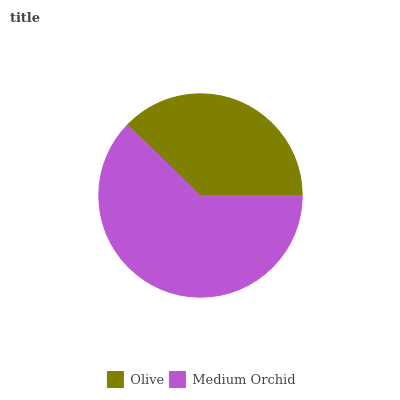Is Olive the minimum?
Answer yes or no. Yes. Is Medium Orchid the maximum?
Answer yes or no. Yes. Is Medium Orchid the minimum?
Answer yes or no. No. Is Medium Orchid greater than Olive?
Answer yes or no. Yes. Is Olive less than Medium Orchid?
Answer yes or no. Yes. Is Olive greater than Medium Orchid?
Answer yes or no. No. Is Medium Orchid less than Olive?
Answer yes or no. No. Is Medium Orchid the high median?
Answer yes or no. Yes. Is Olive the low median?
Answer yes or no. Yes. Is Olive the high median?
Answer yes or no. No. Is Medium Orchid the low median?
Answer yes or no. No. 